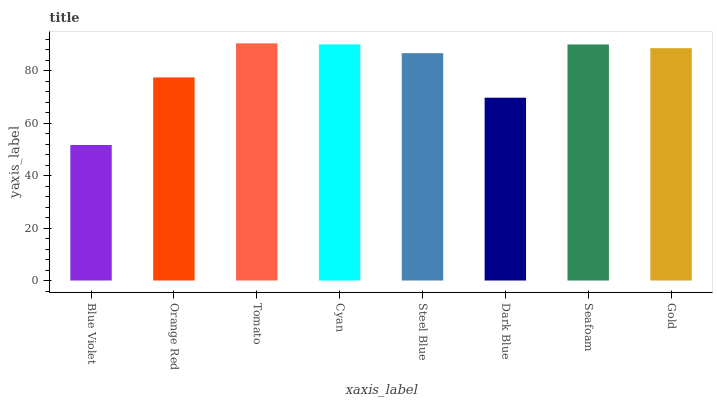Is Blue Violet the minimum?
Answer yes or no. Yes. Is Tomato the maximum?
Answer yes or no. Yes. Is Orange Red the minimum?
Answer yes or no. No. Is Orange Red the maximum?
Answer yes or no. No. Is Orange Red greater than Blue Violet?
Answer yes or no. Yes. Is Blue Violet less than Orange Red?
Answer yes or no. Yes. Is Blue Violet greater than Orange Red?
Answer yes or no. No. Is Orange Red less than Blue Violet?
Answer yes or no. No. Is Gold the high median?
Answer yes or no. Yes. Is Steel Blue the low median?
Answer yes or no. Yes. Is Dark Blue the high median?
Answer yes or no. No. Is Gold the low median?
Answer yes or no. No. 